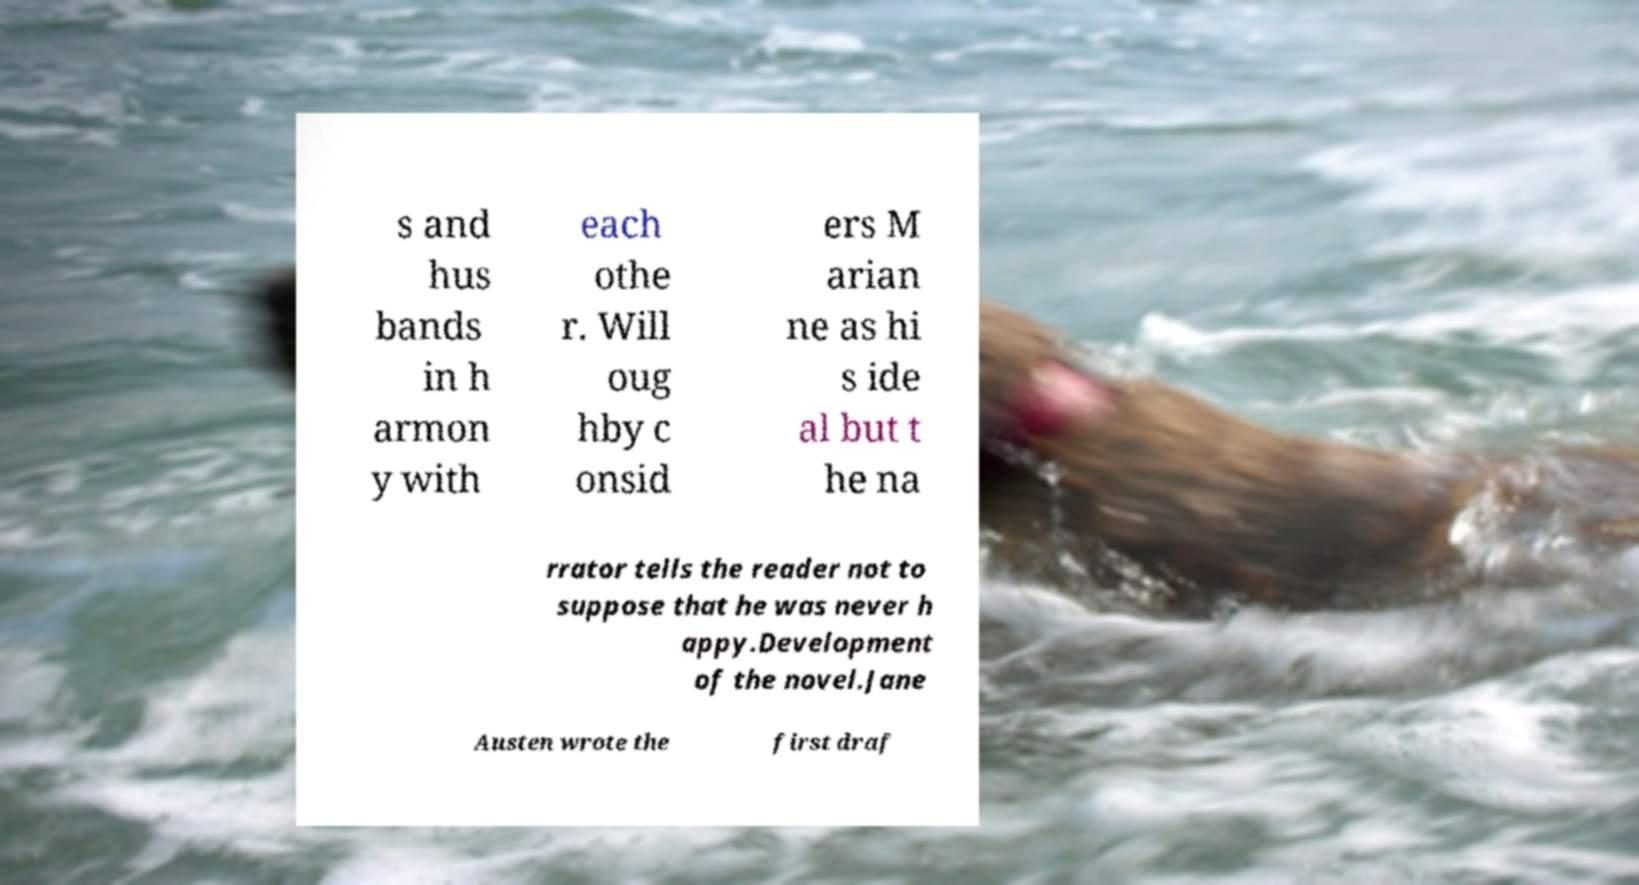I need the written content from this picture converted into text. Can you do that? s and hus bands in h armon y with each othe r. Will oug hby c onsid ers M arian ne as hi s ide al but t he na rrator tells the reader not to suppose that he was never h appy.Development of the novel.Jane Austen wrote the first draf 